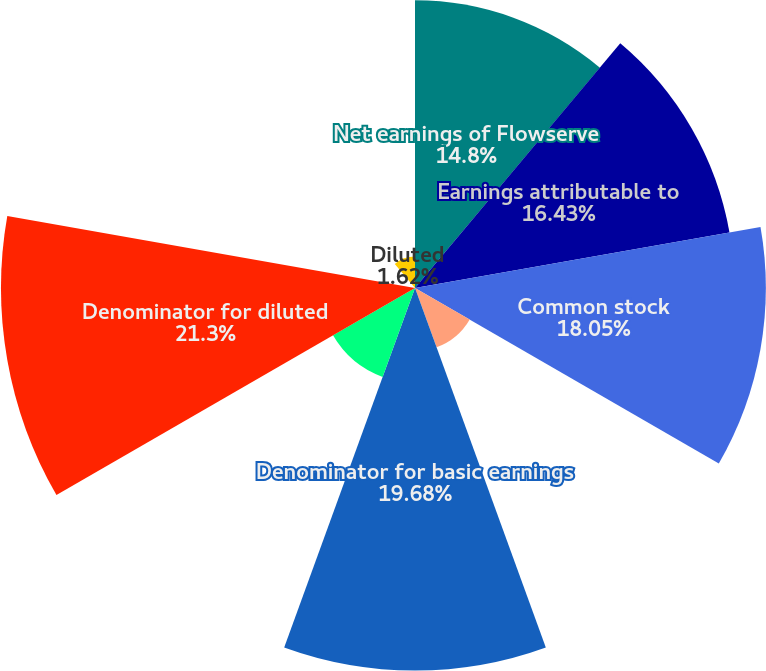Convert chart. <chart><loc_0><loc_0><loc_500><loc_500><pie_chart><fcel>Net earnings of Flowserve<fcel>Earnings attributable to<fcel>Common stock<fcel>Participating securities<fcel>Denominator for basic earnings<fcel>Effect of potentially dilutive<fcel>Denominator for diluted<fcel>Basic<fcel>Diluted<nl><fcel>14.8%<fcel>16.43%<fcel>18.05%<fcel>3.25%<fcel>19.68%<fcel>4.87%<fcel>21.3%<fcel>0.0%<fcel>1.62%<nl></chart> 